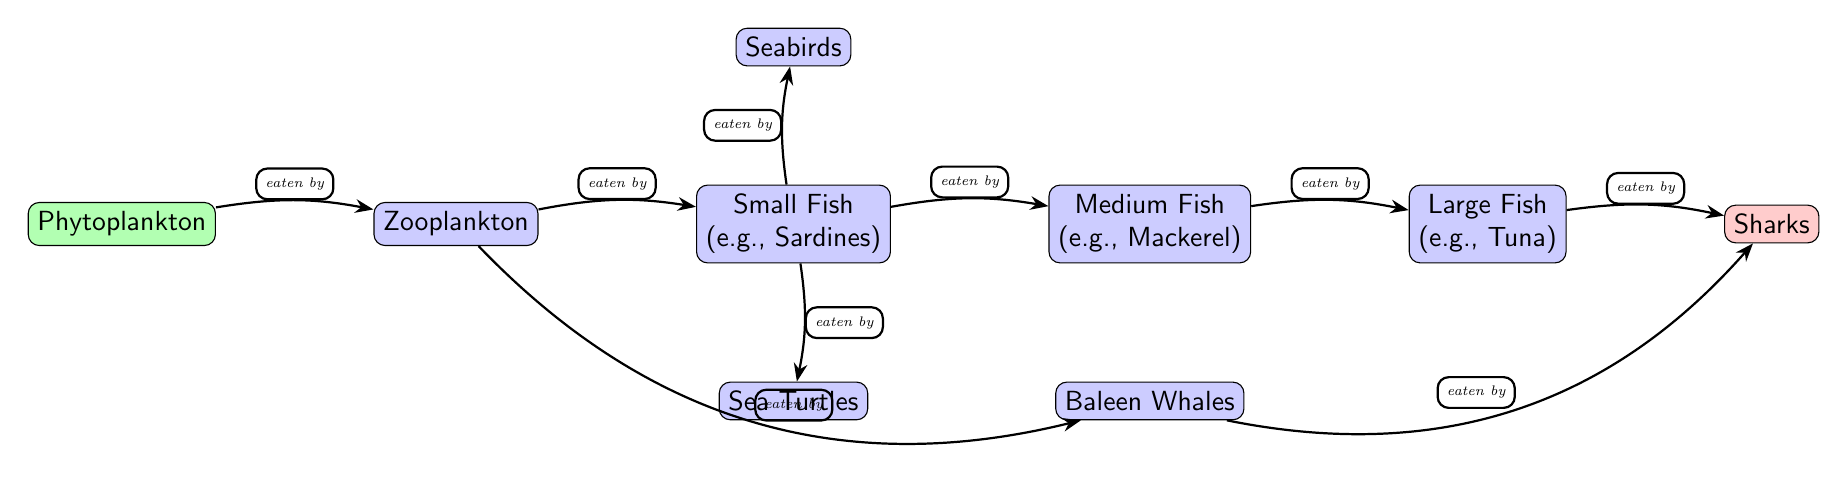What is the first node in the food chain? The food chain starts with Phytoplankton, as it is identified as the producer at the very beginning of the diagram.
Answer: Phytoplankton How many consumer nodes are there in the diagram? By counting all the nodes labeled as consumers, which include Zooplankton, Small Fish, Medium Fish, Large Fish, Seabirds, Sea Turtles, and Baleen Whales, we find there are 7 consumer nodes.
Answer: 7 Which node is eaten by Turtles? Referring to the arrows connecting the nodes, Sea Turtles eat Small Fish, indicated by the directed arrow pointing down from Small Fish to Turtles.
Answer: Small Fish What is the apex predator in this food chain? The diagram identifies Sharks as the apex predator, as it is the last consumer node in the chain with no outgoing arrows further to the right.
Answer: Sharks How many connections (edges) are initiated from Small Fish? The Small Fish node has three outgoing edges: one to Medium Fish, one to Seabirds, and one to Sea Turtles, which means there are three connections.
Answer: 3 What type of fish does Medium Fish eat? According to the diagram, the Medium Fish node is indicated as being eaten by Large Fish, thus it represents a food connection in the chain.
Answer: Large Fish Which two nodes are connected directly through whales? The diagram shows an arrow that connects the Zooplankton node directly to the Baleen Whales node, indicating the direct relationship between these two.
Answer: Zooplankton and Baleen Whales What type of organism is Plankton in this food chain? Plankton, specifically Phytoplankton, is categorized as a producer since it forms the foundation of the food chain and is the first node in the diagram.
Answer: Producer How many apex nodes exist in this food chain? The diagram shows that there is only one apex node, which is Sharks, indicating that it is the top predator in this food chain structure.
Answer: 1 